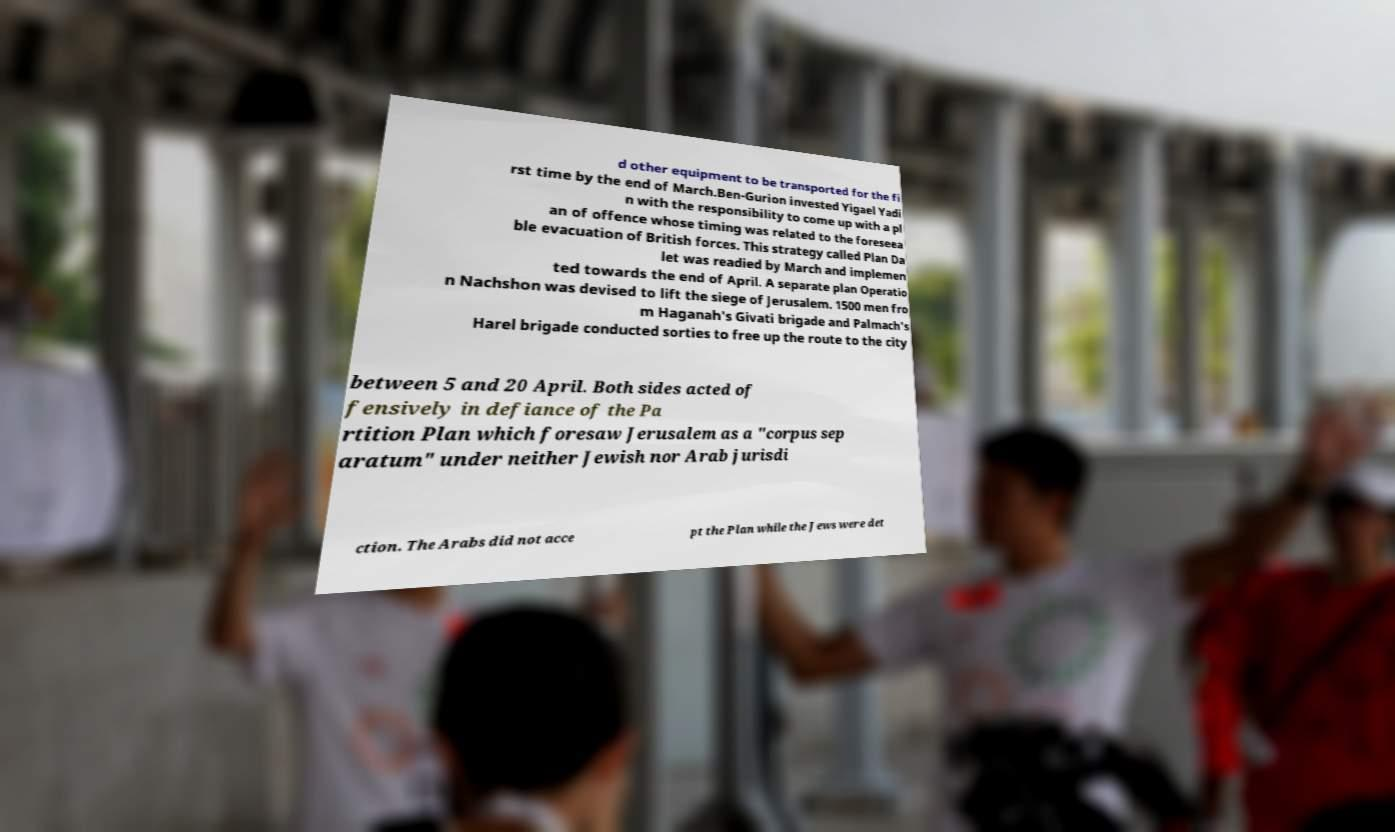Please identify and transcribe the text found in this image. d other equipment to be transported for the fi rst time by the end of March.Ben-Gurion invested Yigael Yadi n with the responsibility to come up with a pl an of offence whose timing was related to the foreseea ble evacuation of British forces. This strategy called Plan Da let was readied by March and implemen ted towards the end of April. A separate plan Operatio n Nachshon was devised to lift the siege of Jerusalem. 1500 men fro m Haganah's Givati brigade and Palmach's Harel brigade conducted sorties to free up the route to the city between 5 and 20 April. Both sides acted of fensively in defiance of the Pa rtition Plan which foresaw Jerusalem as a "corpus sep aratum" under neither Jewish nor Arab jurisdi ction. The Arabs did not acce pt the Plan while the Jews were det 